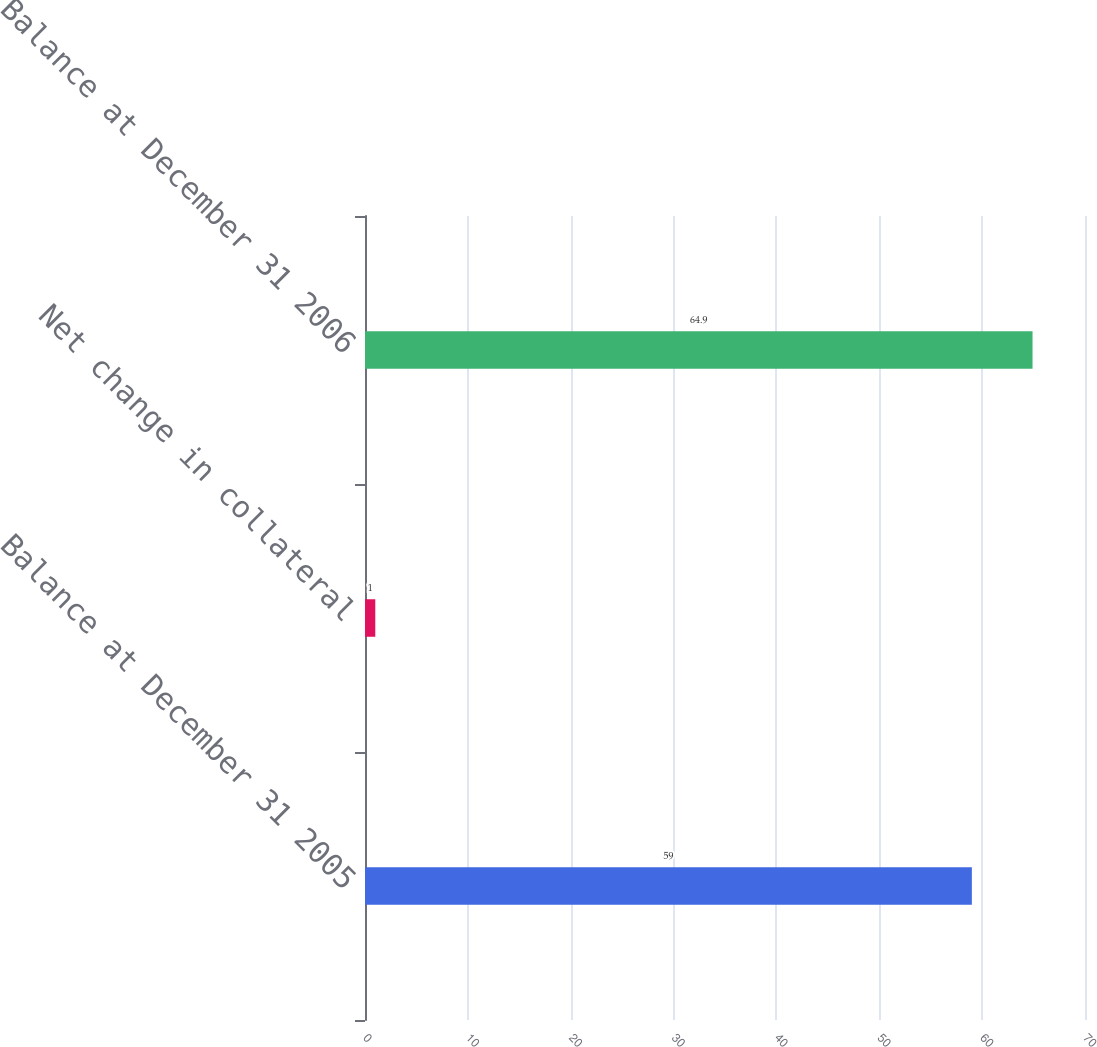Convert chart. <chart><loc_0><loc_0><loc_500><loc_500><bar_chart><fcel>Balance at December 31 2005<fcel>Net change in collateral<fcel>Balance at December 31 2006<nl><fcel>59<fcel>1<fcel>64.9<nl></chart> 